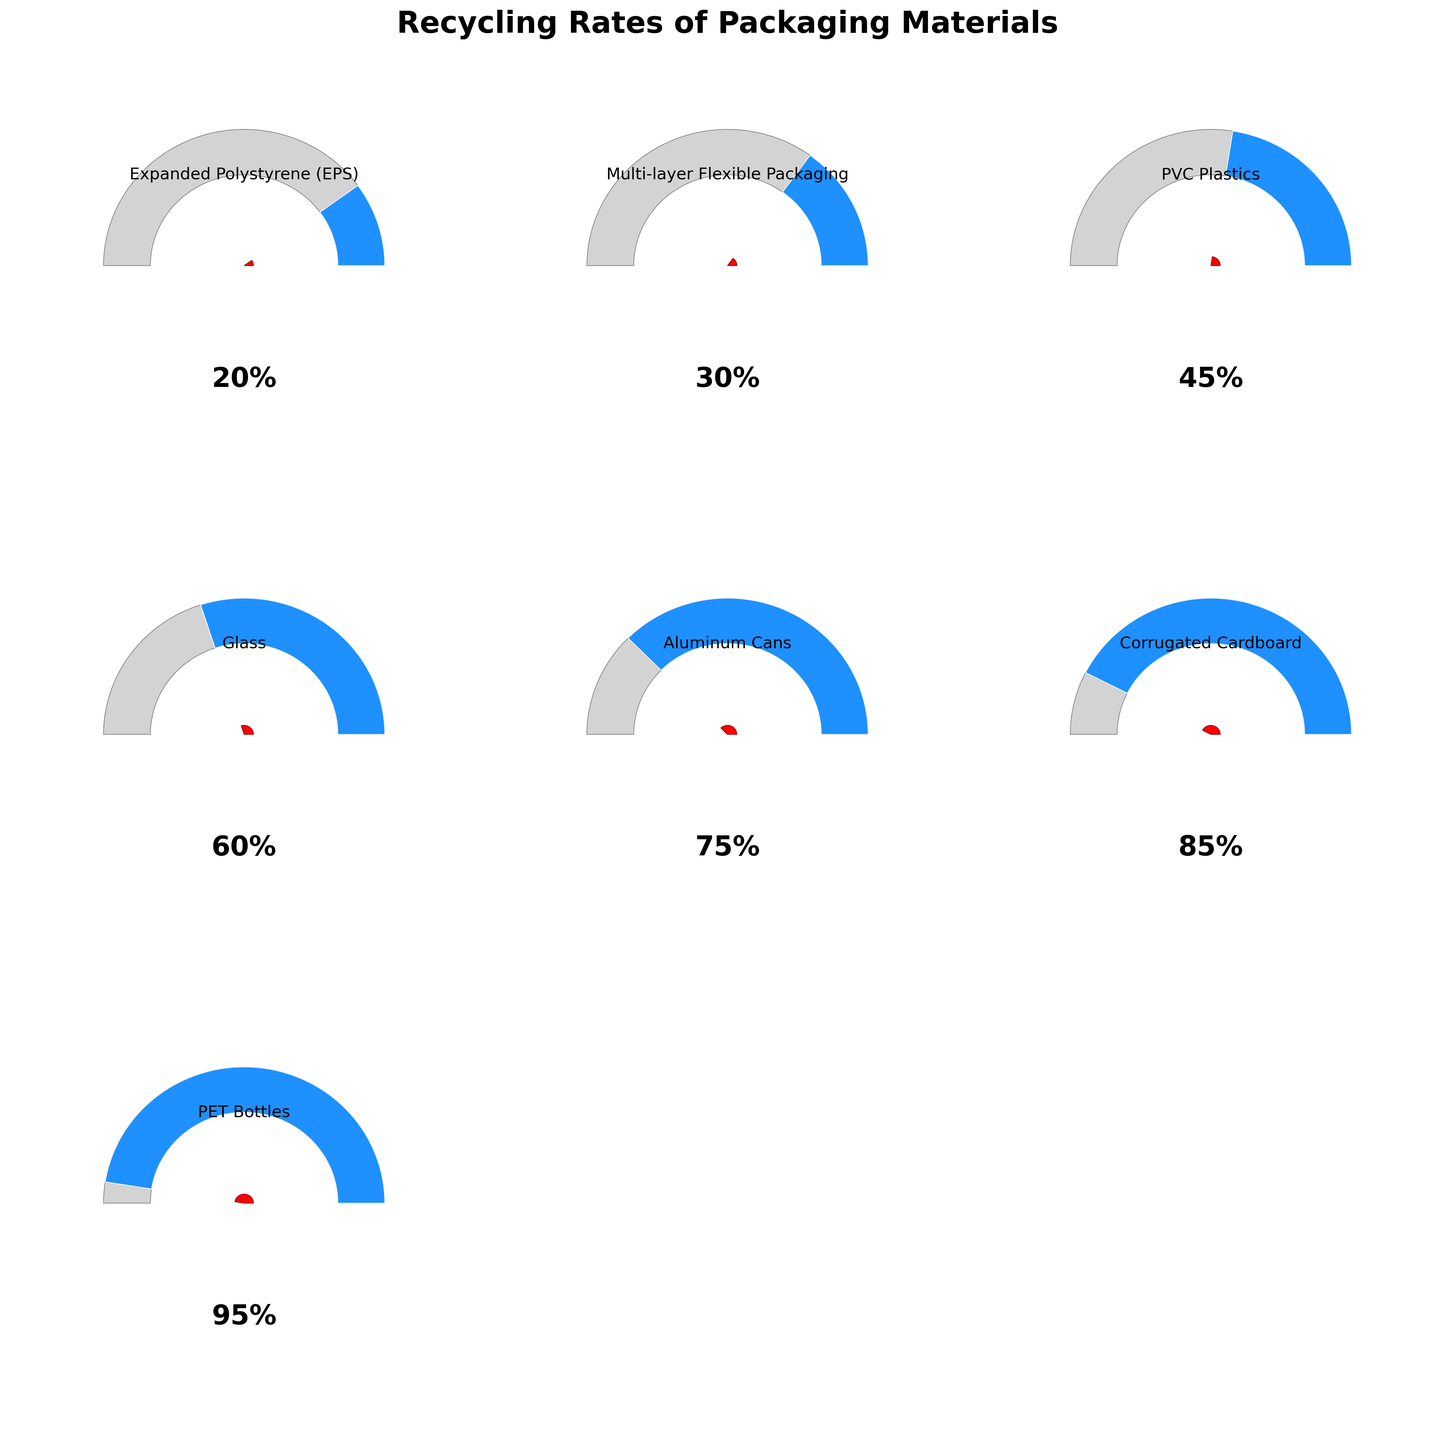Which packaging material has the highest recycling rate? By observing the gauge charts, find the material with the needle closest to 100%. PET Bottles is recorded as having a recycling rate of 95%, which is the highest.
Answer: PET Bottles Which material has a recycling rate of 60%? Identify the gauge chart where the needle points to 60%. For the material labeled under this chart, Glass has a recycling rate of 60%.
Answer: Glass Which two materials have recycling rates above 80%? Identify the gauge charts where the needles are above the 80% mark. Corrugated Cardboard and PET Bottles exceed 80% with rates of 85% and 95%, respectively.
Answer: Corrugated Cardboard, PET Bottles What is the recycling rate difference between Aluminum Cans and Expanded Polystyrene (EPS)? Compare the recycling rates of Aluminum Cans (75%) and EPS (20%). Subtract the smaller percentage from the larger one: 75% - 20% = 55%.
Answer: 55% Which material has the lowest recycling rate? Look for the gauge chart with the needle closest to 0%. Expanded Polystyrene (EPS) has the lowest recycling rate at 20%.
Answer: Expanded Polystyrene (EPS) How many materials have a recycling rate of at least 50%? Count the number of gauge charts where the needle is at or above the 50% mark. Glass (60%), Aluminum Cans (75%), Corrugated Cardboard (85%), and PET Bottles (95%) all meet this criterion. There are 4 materials.
Answer: 4 Which material's recycling rate falls between that of PVC Plastics and Multi-layer Flexible Packaging? Check the rates given: Multi-layer Flexible Packaging at 30% and PVC Plastics at 45%. Any material between these two percentages falls in the range. Multi-layer Flexible Packaging lies between EPS and PVC Plastics in this list with a rate itself at 30%. Check for a mistake in phrasing: likely this intends a comparative judgment.
Answer: None (correct phrased example-dependent) What is the average recycling rate for the materials listed? Sum the recycling rates (20%, 30%, 45%, 60%, 75%, 85%, 95%), then divide by the number of materials (7): (20 + 30 + 45 + 60 + 75 + 85 + 95) / 7 = 58.57% (approximately 58.6%).
Answer: 58.6% Which materials have recycling rates less than 50%? Identify the gauge charts where the needle is below the 50% mark. Expanded Polystyrene (EPS) with 20%, Multi-layer Flexible Packaging with 30%, and PVC Plastics with 45% meet this criterion.
Answer: EPS, Multi-layer Flexible Packaging, PVC Plastics Are there more materials with recycling rates above 50% or below 50%? Count the number of gauge charts with recycling rates above and below 50%. Four materials (Glass, Aluminum Cans, Corrugated Cardboard, PET Bottles) are above 50%, and three (EPS, Multi-layer Flexible Packaging, PVC Plastics) are below 50%. Thus, there are more materials above 50% than below.
Answer: Above 50% 